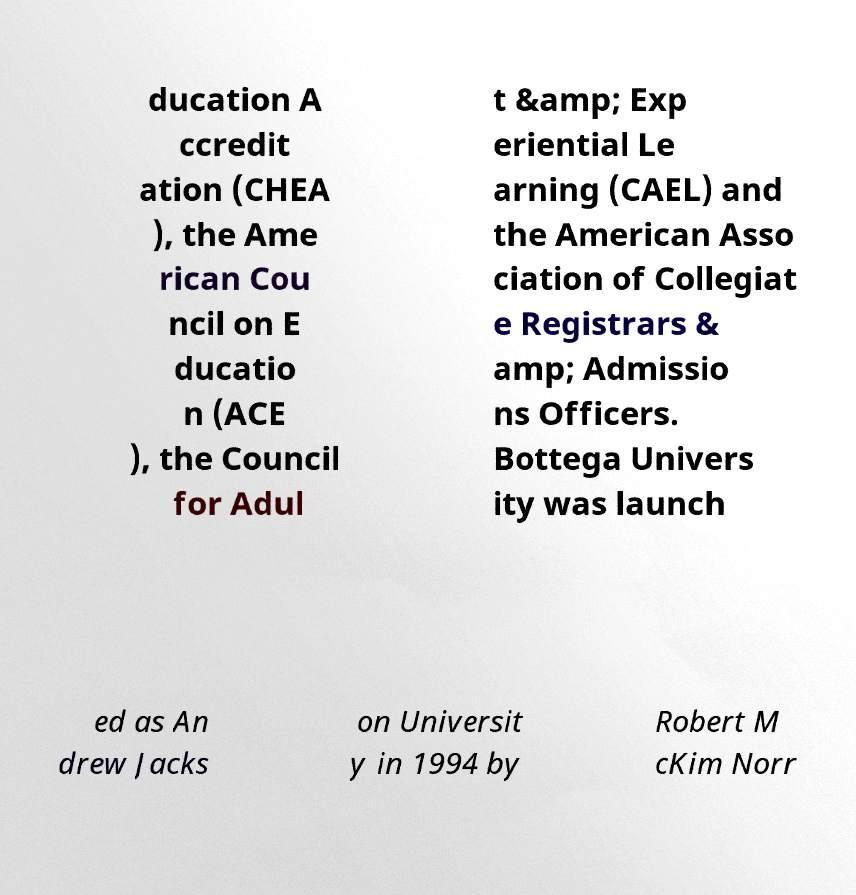Could you assist in decoding the text presented in this image and type it out clearly? ducation A ccredit ation (CHEA ), the Ame rican Cou ncil on E ducatio n (ACE ), the Council for Adul t &amp; Exp eriential Le arning (CAEL) and the American Asso ciation of Collegiat e Registrars & amp; Admissio ns Officers. Bottega Univers ity was launch ed as An drew Jacks on Universit y in 1994 by Robert M cKim Norr 